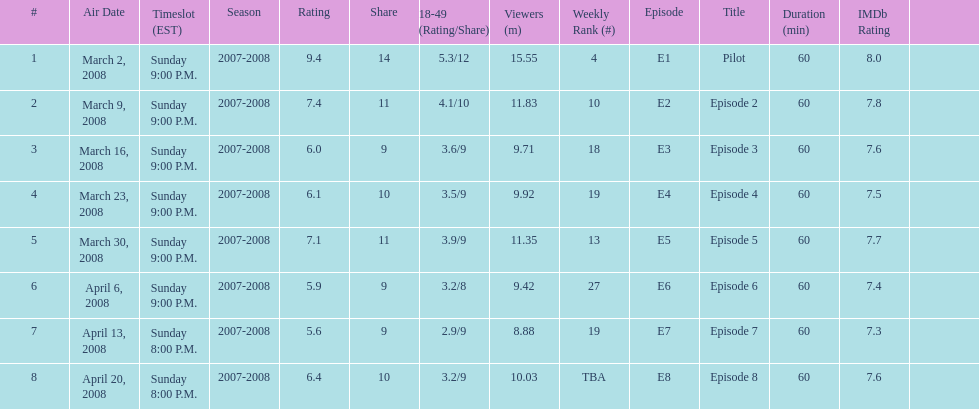How long did the program air for in days? 8. 